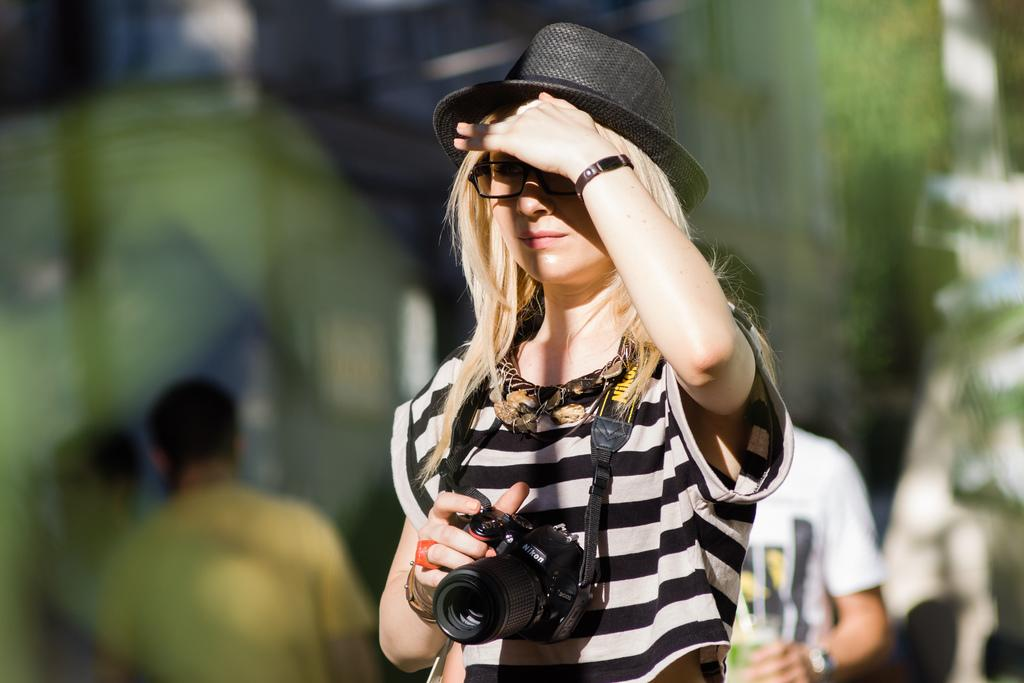How many people are in the image? There are a few people in the image. What is one person doing in the image? One person is holding a camera. Can you describe the background of the image? The background of the image is blurred. What type of clam can be seen in the image? There is no clam present in the image. Can you tell me the account number of the person holding the camera? There is no account number mentioned or visible in the image. 